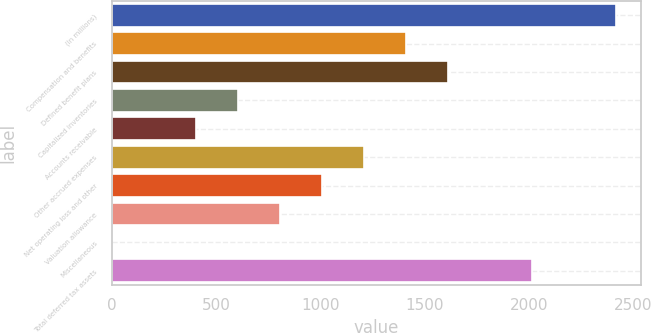Convert chart to OTSL. <chart><loc_0><loc_0><loc_500><loc_500><bar_chart><fcel>(In millions)<fcel>Compensation and benefits<fcel>Defined benefit plans<fcel>Capitalized inventories<fcel>Accounts receivable<fcel>Other accrued expenses<fcel>Net operating loss and other<fcel>Valuation allowance<fcel>Miscellaneous<fcel>Total deferred tax assets<nl><fcel>2418.7<fcel>1411.95<fcel>1613.3<fcel>606.55<fcel>405.2<fcel>1210.6<fcel>1009.25<fcel>807.9<fcel>2.5<fcel>2016<nl></chart> 